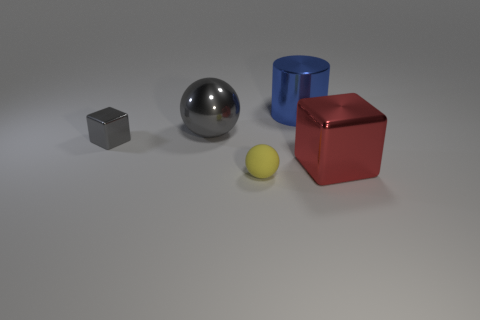What material is the small yellow sphere?
Your answer should be very brief. Rubber. How big is the shiny block left of the large red shiny cube?
Your answer should be very brief. Small. Is there any other thing that is the same color as the big shiny block?
Make the answer very short. No. There is a object that is in front of the large object in front of the big gray thing; are there any balls that are in front of it?
Offer a very short reply. No. There is a ball that is in front of the red cube; is it the same color as the small metallic block?
Offer a terse response. No. How many cylinders are either red rubber objects or blue objects?
Your answer should be very brief. 1. The small thing that is in front of the metallic block on the right side of the small cube is what shape?
Your answer should be compact. Sphere. How big is the gray metallic sphere that is behind the cube that is in front of the small object that is behind the yellow thing?
Provide a short and direct response. Large. Is the gray sphere the same size as the yellow matte thing?
Offer a terse response. No. How many things are either big red objects or gray metallic cubes?
Make the answer very short. 2. 